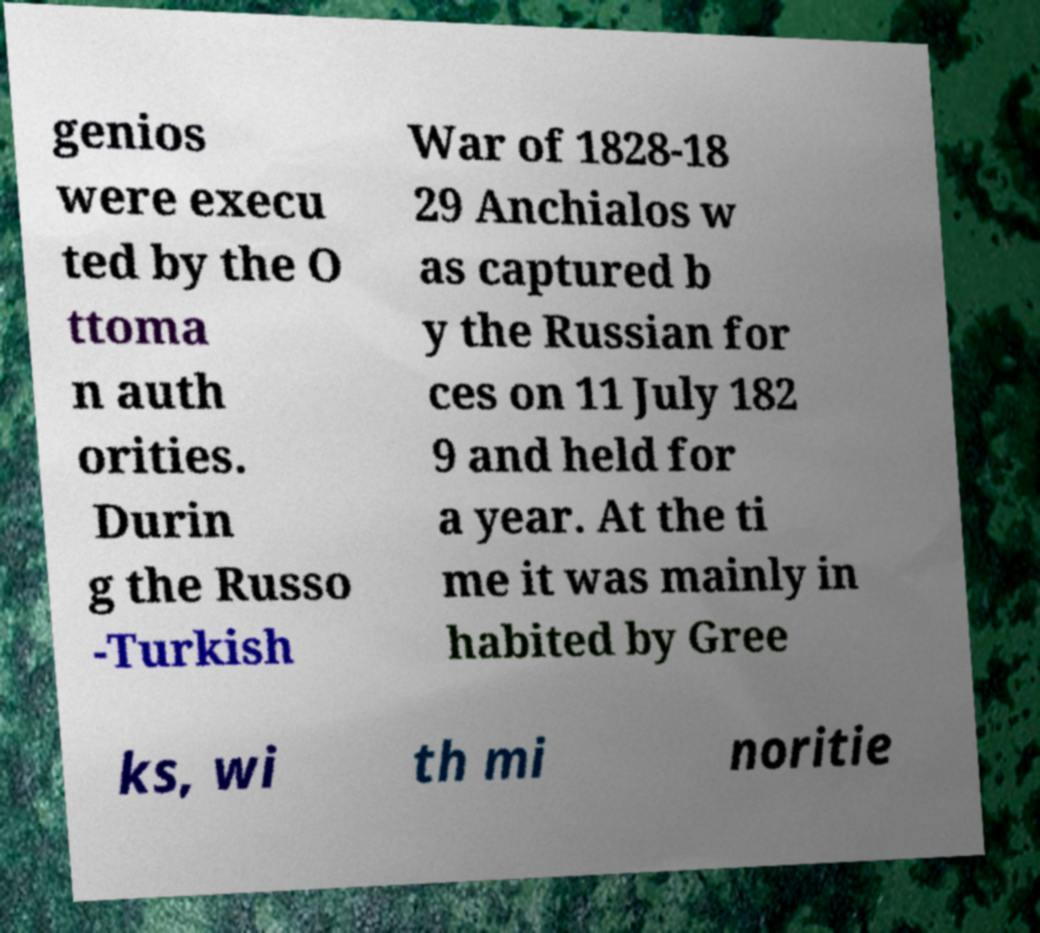What messages or text are displayed in this image? I need them in a readable, typed format. genios were execu ted by the O ttoma n auth orities. Durin g the Russo -Turkish War of 1828-18 29 Anchialos w as captured b y the Russian for ces on 11 July 182 9 and held for a year. At the ti me it was mainly in habited by Gree ks, wi th mi noritie 